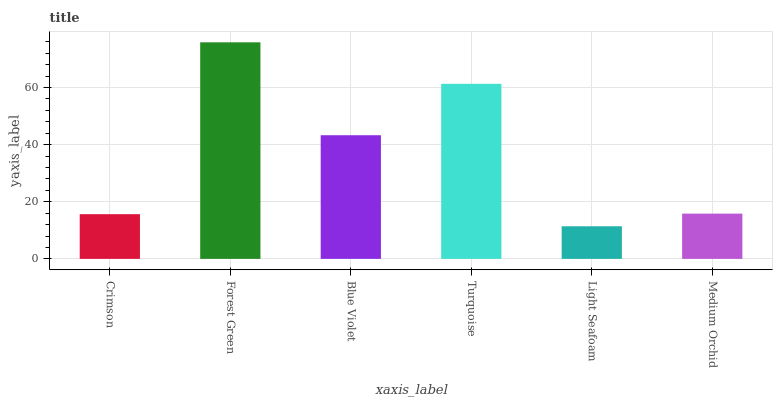Is Light Seafoam the minimum?
Answer yes or no. Yes. Is Forest Green the maximum?
Answer yes or no. Yes. Is Blue Violet the minimum?
Answer yes or no. No. Is Blue Violet the maximum?
Answer yes or no. No. Is Forest Green greater than Blue Violet?
Answer yes or no. Yes. Is Blue Violet less than Forest Green?
Answer yes or no. Yes. Is Blue Violet greater than Forest Green?
Answer yes or no. No. Is Forest Green less than Blue Violet?
Answer yes or no. No. Is Blue Violet the high median?
Answer yes or no. Yes. Is Medium Orchid the low median?
Answer yes or no. Yes. Is Crimson the high median?
Answer yes or no. No. Is Crimson the low median?
Answer yes or no. No. 